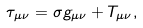Convert formula to latex. <formula><loc_0><loc_0><loc_500><loc_500>\tau _ { \mu \nu } = \sigma g _ { \mu \nu } + T _ { \mu \nu } ,</formula> 